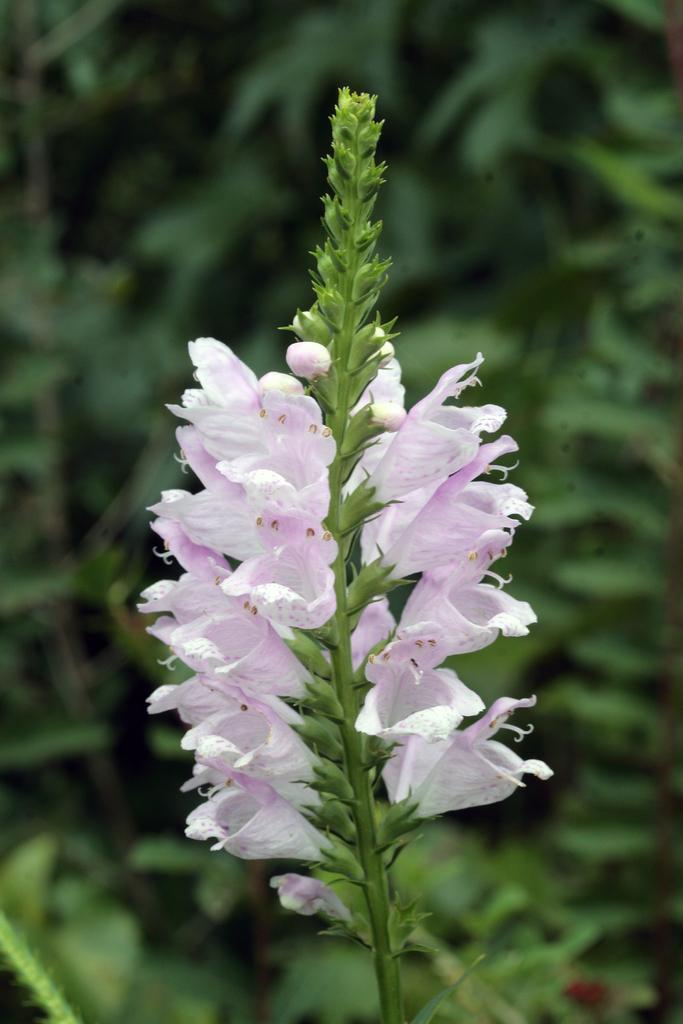In one or two sentences, can you explain what this image depicts? In this picture there is a flower plant in the center of the image and there are other plants in the background area of the image. 